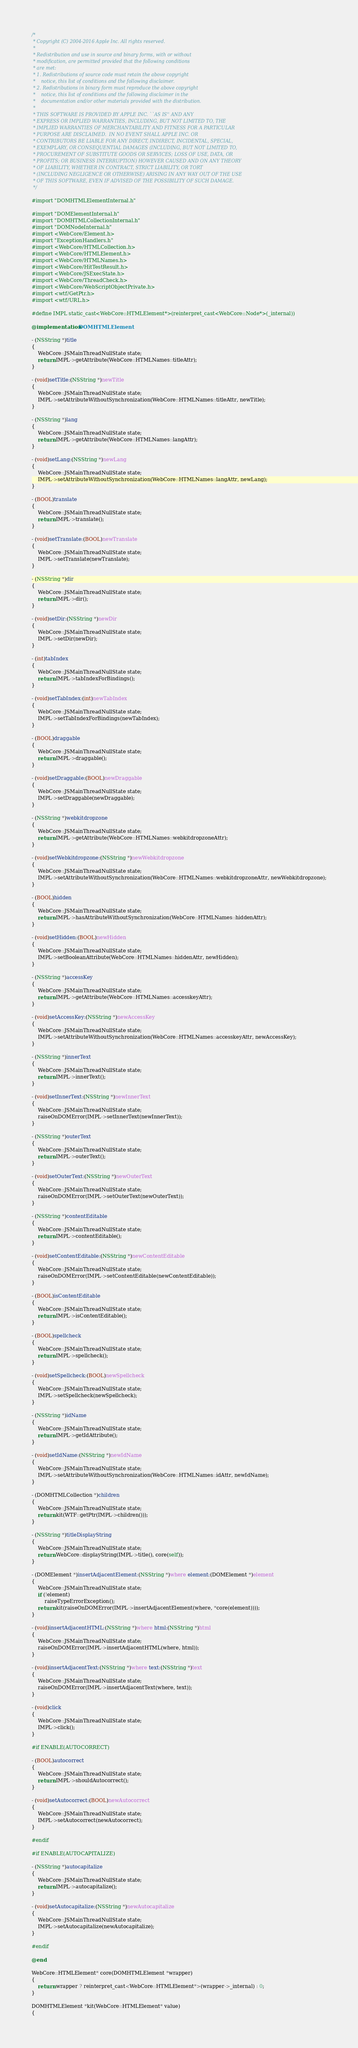<code> <loc_0><loc_0><loc_500><loc_500><_ObjectiveC_>/*
 * Copyright (C) 2004-2016 Apple Inc. All rights reserved.
 *
 * Redistribution and use in source and binary forms, with or without
 * modification, are permitted provided that the following conditions
 * are met:
 * 1. Redistributions of source code must retain the above copyright
 *    notice, this list of conditions and the following disclaimer.
 * 2. Redistributions in binary form must reproduce the above copyright
 *    notice, this list of conditions and the following disclaimer in the
 *    documentation and/or other materials provided with the distribution.
 *
 * THIS SOFTWARE IS PROVIDED BY APPLE INC. ``AS IS'' AND ANY
 * EXPRESS OR IMPLIED WARRANTIES, INCLUDING, BUT NOT LIMITED TO, THE
 * IMPLIED WARRANTIES OF MERCHANTABILITY AND FITNESS FOR A PARTICULAR
 * PURPOSE ARE DISCLAIMED.  IN NO EVENT SHALL APPLE INC. OR
 * CONTRIBUTORS BE LIABLE FOR ANY DIRECT, INDIRECT, INCIDENTAL, SPECIAL,
 * EXEMPLARY, OR CONSEQUENTIAL DAMAGES (INCLUDING, BUT NOT LIMITED TO,
 * PROCUREMENT OF SUBSTITUTE GOODS OR SERVICES; LOSS OF USE, DATA, OR
 * PROFITS; OR BUSINESS INTERRUPTION) HOWEVER CAUSED AND ON ANY THEORY
 * OF LIABILITY, WHETHER IN CONTRACT, STRICT LIABILITY, OR TORT
 * (INCLUDING NEGLIGENCE OR OTHERWISE) ARISING IN ANY WAY OUT OF THE USE
 * OF THIS SOFTWARE, EVEN IF ADVISED OF THE POSSIBILITY OF SUCH DAMAGE.
 */

#import "DOMHTMLElementInternal.h"

#import "DOMElementInternal.h"
#import "DOMHTMLCollectionInternal.h"
#import "DOMNodeInternal.h"
#import <WebCore/Element.h>
#import "ExceptionHandlers.h"
#import <WebCore/HTMLCollection.h>
#import <WebCore/HTMLElement.h>
#import <WebCore/HTMLNames.h>
#import <WebCore/HitTestResult.h>
#import <WebCore/JSExecState.h>
#import <WebCore/ThreadCheck.h>
#import <WebCore/WebScriptObjectPrivate.h>
#import <wtf/GetPtr.h>
#import <wtf/URL.h>

#define IMPL static_cast<WebCore::HTMLElement*>(reinterpret_cast<WebCore::Node*>(_internal))

@implementation DOMHTMLElement

- (NSString *)title
{
    WebCore::JSMainThreadNullState state;
    return IMPL->getAttribute(WebCore::HTMLNames::titleAttr);
}

- (void)setTitle:(NSString *)newTitle
{
    WebCore::JSMainThreadNullState state;
    IMPL->setAttributeWithoutSynchronization(WebCore::HTMLNames::titleAttr, newTitle);
}

- (NSString *)lang
{
    WebCore::JSMainThreadNullState state;
    return IMPL->getAttribute(WebCore::HTMLNames::langAttr);
}

- (void)setLang:(NSString *)newLang
{
    WebCore::JSMainThreadNullState state;
    IMPL->setAttributeWithoutSynchronization(WebCore::HTMLNames::langAttr, newLang);
}

- (BOOL)translate
{
    WebCore::JSMainThreadNullState state;
    return IMPL->translate();
}

- (void)setTranslate:(BOOL)newTranslate
{
    WebCore::JSMainThreadNullState state;
    IMPL->setTranslate(newTranslate);
}

- (NSString *)dir
{
    WebCore::JSMainThreadNullState state;
    return IMPL->dir();
}

- (void)setDir:(NSString *)newDir
{
    WebCore::JSMainThreadNullState state;
    IMPL->setDir(newDir);
}

- (int)tabIndex
{
    WebCore::JSMainThreadNullState state;
    return IMPL->tabIndexForBindings();
}

- (void)setTabIndex:(int)newTabIndex
{
    WebCore::JSMainThreadNullState state;
    IMPL->setTabIndexForBindings(newTabIndex);
}

- (BOOL)draggable
{
    WebCore::JSMainThreadNullState state;
    return IMPL->draggable();
}

- (void)setDraggable:(BOOL)newDraggable
{
    WebCore::JSMainThreadNullState state;
    IMPL->setDraggable(newDraggable);
}

- (NSString *)webkitdropzone
{
    WebCore::JSMainThreadNullState state;
    return IMPL->getAttribute(WebCore::HTMLNames::webkitdropzoneAttr);
}

- (void)setWebkitdropzone:(NSString *)newWebkitdropzone
{
    WebCore::JSMainThreadNullState state;
    IMPL->setAttributeWithoutSynchronization(WebCore::HTMLNames::webkitdropzoneAttr, newWebkitdropzone);
}

- (BOOL)hidden
{
    WebCore::JSMainThreadNullState state;
    return IMPL->hasAttributeWithoutSynchronization(WebCore::HTMLNames::hiddenAttr);
}

- (void)setHidden:(BOOL)newHidden
{
    WebCore::JSMainThreadNullState state;
    IMPL->setBooleanAttribute(WebCore::HTMLNames::hiddenAttr, newHidden);
}

- (NSString *)accessKey
{
    WebCore::JSMainThreadNullState state;
    return IMPL->getAttribute(WebCore::HTMLNames::accesskeyAttr);
}

- (void)setAccessKey:(NSString *)newAccessKey
{
    WebCore::JSMainThreadNullState state;
    IMPL->setAttributeWithoutSynchronization(WebCore::HTMLNames::accesskeyAttr, newAccessKey);
}

- (NSString *)innerText
{
    WebCore::JSMainThreadNullState state;
    return IMPL->innerText();
}

- (void)setInnerText:(NSString *)newInnerText
{
    WebCore::JSMainThreadNullState state;
    raiseOnDOMError(IMPL->setInnerText(newInnerText));
}

- (NSString *)outerText
{
    WebCore::JSMainThreadNullState state;
    return IMPL->outerText();
}

- (void)setOuterText:(NSString *)newOuterText
{
    WebCore::JSMainThreadNullState state;
    raiseOnDOMError(IMPL->setOuterText(newOuterText));
}

- (NSString *)contentEditable
{
    WebCore::JSMainThreadNullState state;
    return IMPL->contentEditable();
}

- (void)setContentEditable:(NSString *)newContentEditable
{
    WebCore::JSMainThreadNullState state;
    raiseOnDOMError(IMPL->setContentEditable(newContentEditable));
}

- (BOOL)isContentEditable
{
    WebCore::JSMainThreadNullState state;
    return IMPL->isContentEditable();
}

- (BOOL)spellcheck
{
    WebCore::JSMainThreadNullState state;
    return IMPL->spellcheck();
}

- (void)setSpellcheck:(BOOL)newSpellcheck
{
    WebCore::JSMainThreadNullState state;
    IMPL->setSpellcheck(newSpellcheck);
}

- (NSString *)idName
{
    WebCore::JSMainThreadNullState state;
    return IMPL->getIdAttribute();
}

- (void)setIdName:(NSString *)newIdName
{
    WebCore::JSMainThreadNullState state;
    IMPL->setAttributeWithoutSynchronization(WebCore::HTMLNames::idAttr, newIdName);
}

- (DOMHTMLCollection *)children
{
    WebCore::JSMainThreadNullState state;
    return kit(WTF::getPtr(IMPL->children()));
}

- (NSString *)titleDisplayString
{
    WebCore::JSMainThreadNullState state;
    return WebCore::displayString(IMPL->title(), core(self));
}

- (DOMElement *)insertAdjacentElement:(NSString *)where element:(DOMElement *)element
{
    WebCore::JSMainThreadNullState state;
    if (!element)
        raiseTypeErrorException();
    return kit(raiseOnDOMError(IMPL->insertAdjacentElement(where, *core(element))));
}

- (void)insertAdjacentHTML:(NSString *)where html:(NSString *)html
{
    WebCore::JSMainThreadNullState state;
    raiseOnDOMError(IMPL->insertAdjacentHTML(where, html));
}

- (void)insertAdjacentText:(NSString *)where text:(NSString *)text
{
    WebCore::JSMainThreadNullState state;
    raiseOnDOMError(IMPL->insertAdjacentText(where, text));
}

- (void)click
{
    WebCore::JSMainThreadNullState state;
    IMPL->click();
}

#if ENABLE(AUTOCORRECT)

- (BOOL)autocorrect
{
    WebCore::JSMainThreadNullState state;
    return IMPL->shouldAutocorrect();
}

- (void)setAutocorrect:(BOOL)newAutocorrect
{
    WebCore::JSMainThreadNullState state;
    IMPL->setAutocorrect(newAutocorrect);
}

#endif

#if ENABLE(AUTOCAPITALIZE)

- (NSString *)autocapitalize
{
    WebCore::JSMainThreadNullState state;
    return IMPL->autocapitalize();
}

- (void)setAutocapitalize:(NSString *)newAutocapitalize
{
    WebCore::JSMainThreadNullState state;
    IMPL->setAutocapitalize(newAutocapitalize);
}

#endif

@end

WebCore::HTMLElement* core(DOMHTMLElement *wrapper)
{
    return wrapper ? reinterpret_cast<WebCore::HTMLElement*>(wrapper->_internal) : 0;
}

DOMHTMLElement *kit(WebCore::HTMLElement* value)
{</code> 